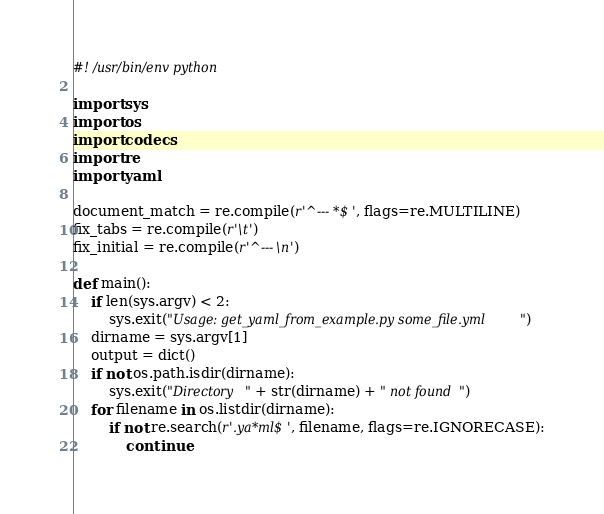<code> <loc_0><loc_0><loc_500><loc_500><_Python_>#! /usr/bin/env python

import sys
import os
import codecs
import re
import yaml

document_match = re.compile(r'^--- *$', flags=re.MULTILINE)
fix_tabs = re.compile(r'\t')
fix_initial = re.compile(r'^---\n')

def main():
    if len(sys.argv) < 2:
        sys.exit("Usage: get_yaml_from_example.py some_file.yml")
    dirname = sys.argv[1]
    output = dict()
    if not os.path.isdir(dirname):
        sys.exit("Directory " + str(dirname) + " not found")
    for filename in os.listdir(dirname):
        if not re.search(r'.ya*ml$', filename, flags=re.IGNORECASE):
            continue</code> 